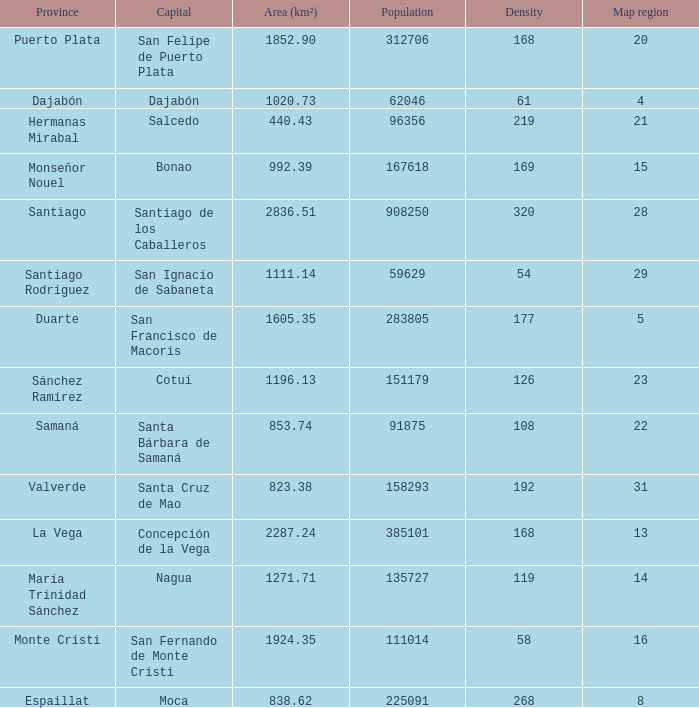When province is monseñor nouel, what is the area (km²)? 992.39. 